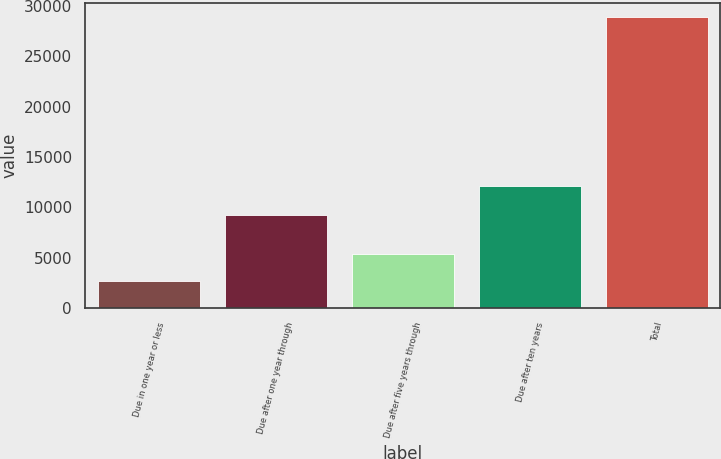Convert chart to OTSL. <chart><loc_0><loc_0><loc_500><loc_500><bar_chart><fcel>Due in one year or less<fcel>Due after one year through<fcel>Due after five years through<fcel>Due after ten years<fcel>Total<nl><fcel>2707<fcel>9210<fcel>5324.9<fcel>12147<fcel>28886<nl></chart> 